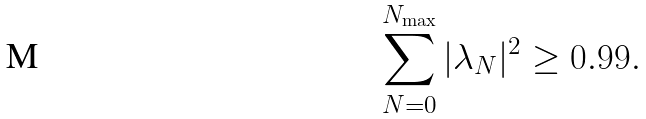<formula> <loc_0><loc_0><loc_500><loc_500>\sum _ { N = 0 } ^ { N _ { \max } } | \lambda _ { N } | ^ { 2 } \geq 0 . 9 9 .</formula> 